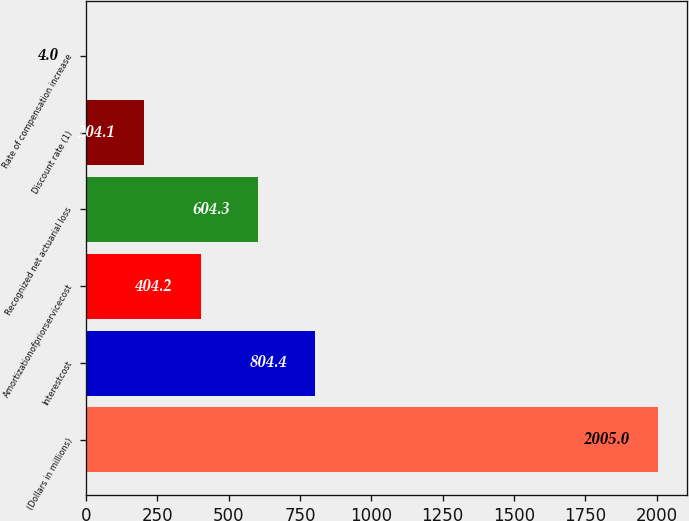Convert chart to OTSL. <chart><loc_0><loc_0><loc_500><loc_500><bar_chart><fcel>(Dollars in millions)<fcel>Interestcost<fcel>Amortizationofpriorservicecost<fcel>Recognized net actuarial loss<fcel>Discount rate (1)<fcel>Rate of compensation increase<nl><fcel>2005<fcel>804.4<fcel>404.2<fcel>604.3<fcel>204.1<fcel>4<nl></chart> 